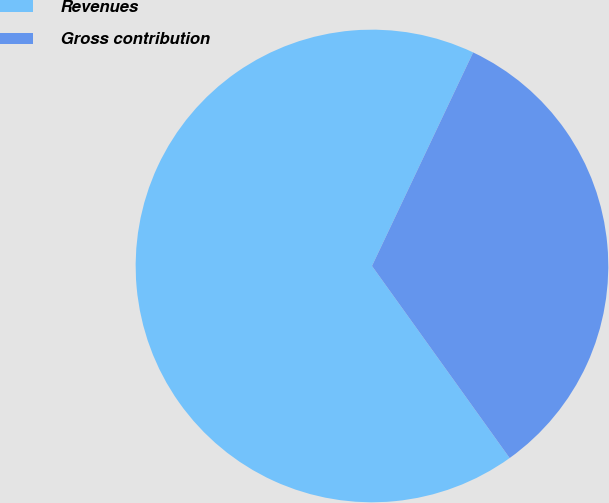Convert chart. <chart><loc_0><loc_0><loc_500><loc_500><pie_chart><fcel>Revenues<fcel>Gross contribution<nl><fcel>66.94%<fcel>33.06%<nl></chart> 